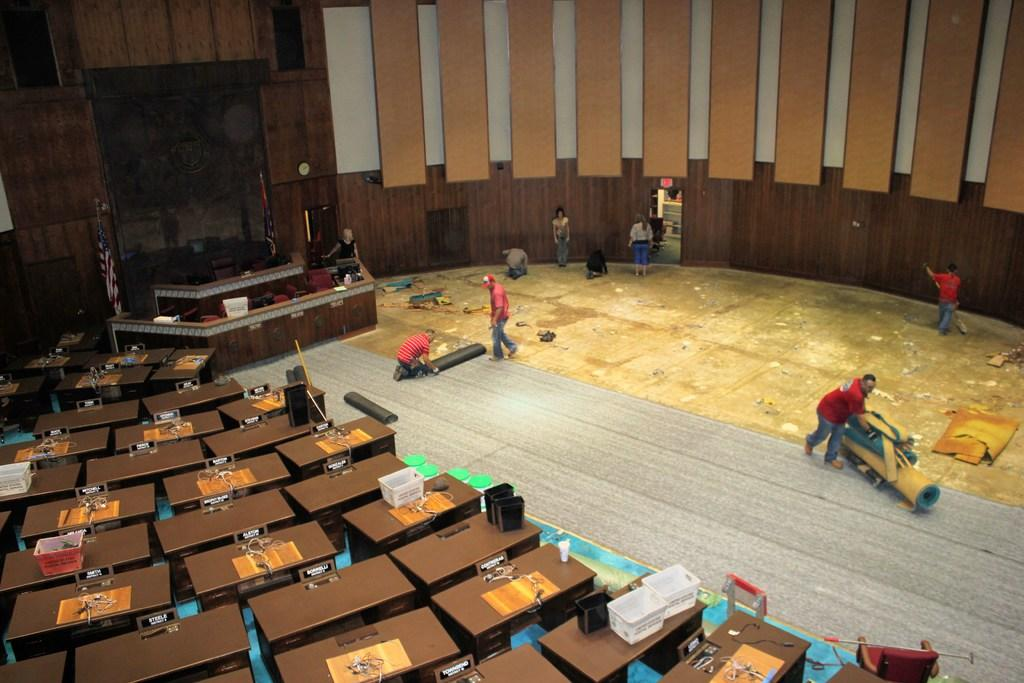What type of space is depicted in the image? There is an auditorium in the picture. What type of seating is available in the auditorium? There are benches and sitting chairs in the auditorium. Are there any tables in the auditorium? Yes, there are tables in the auditorium. What are the people in the image doing? There are people standing in the auditorium. What type of organization is being held in the auditorium? The image does not provide information about the type of organization or event taking place in the auditorium. Can you see any celery being served in the auditorium? There is no celery visible in the image. 